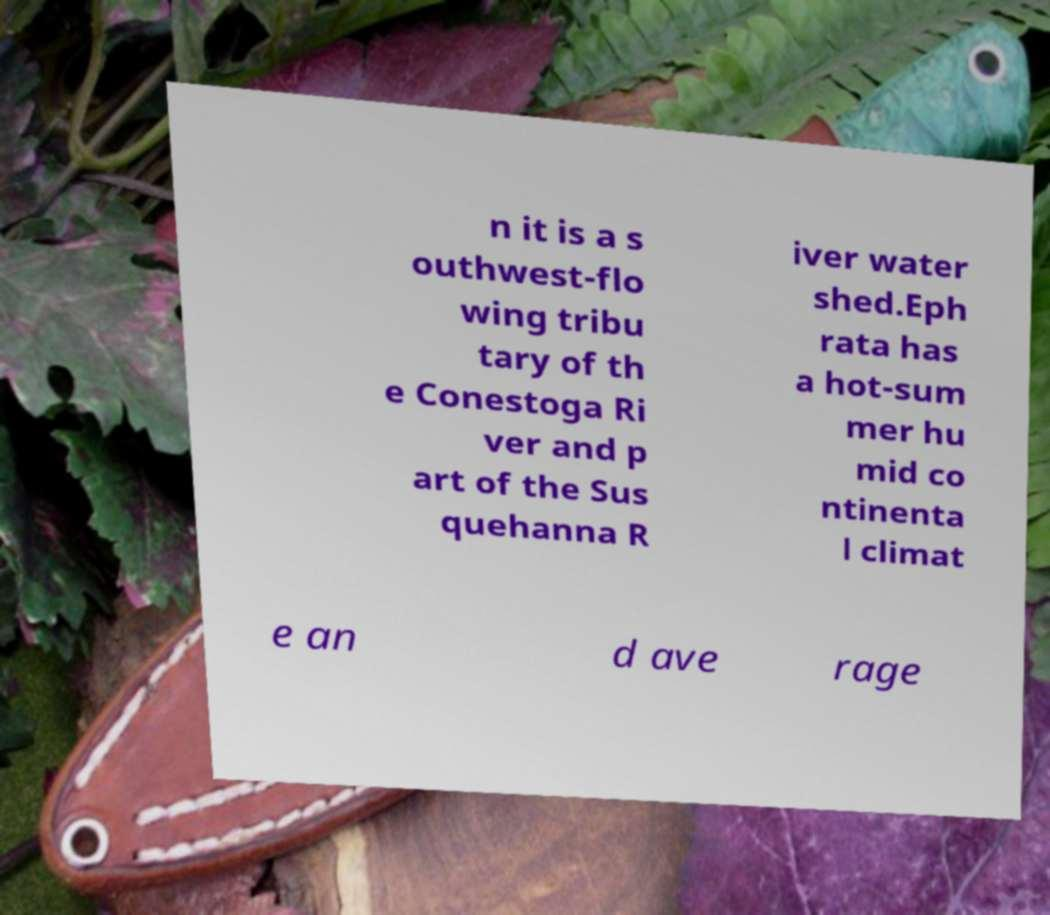Can you accurately transcribe the text from the provided image for me? n it is a s outhwest-flo wing tribu tary of th e Conestoga Ri ver and p art of the Sus quehanna R iver water shed.Eph rata has a hot-sum mer hu mid co ntinenta l climat e an d ave rage 